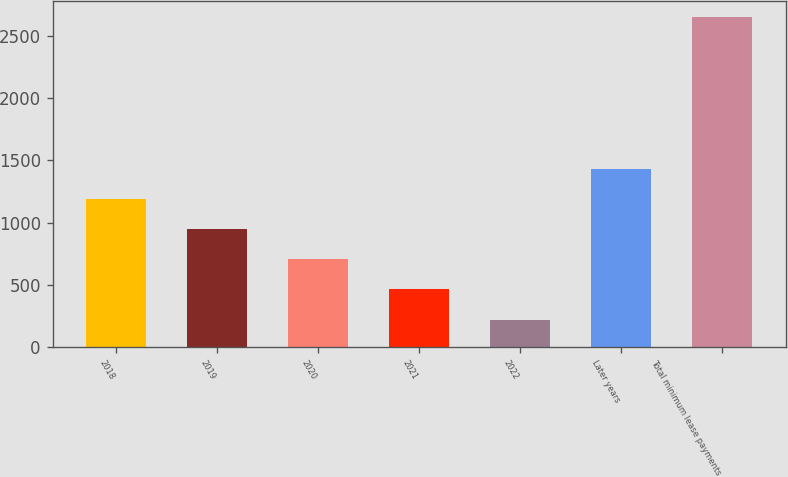<chart> <loc_0><loc_0><loc_500><loc_500><bar_chart><fcel>2018<fcel>2019<fcel>2020<fcel>2021<fcel>2022<fcel>Later years<fcel>Total minimum lease payments<nl><fcel>1192.2<fcel>949.4<fcel>706.6<fcel>463.8<fcel>221<fcel>1435<fcel>2649<nl></chart> 